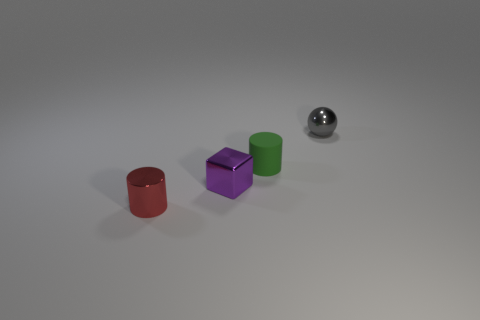Add 2 gray balls. How many objects exist? 6 Subtract all cubes. How many objects are left? 3 Add 2 large green cylinders. How many large green cylinders exist? 2 Subtract 0 yellow spheres. How many objects are left? 4 Subtract all blue matte objects. Subtract all tiny shiny things. How many objects are left? 1 Add 3 small gray things. How many small gray things are left? 4 